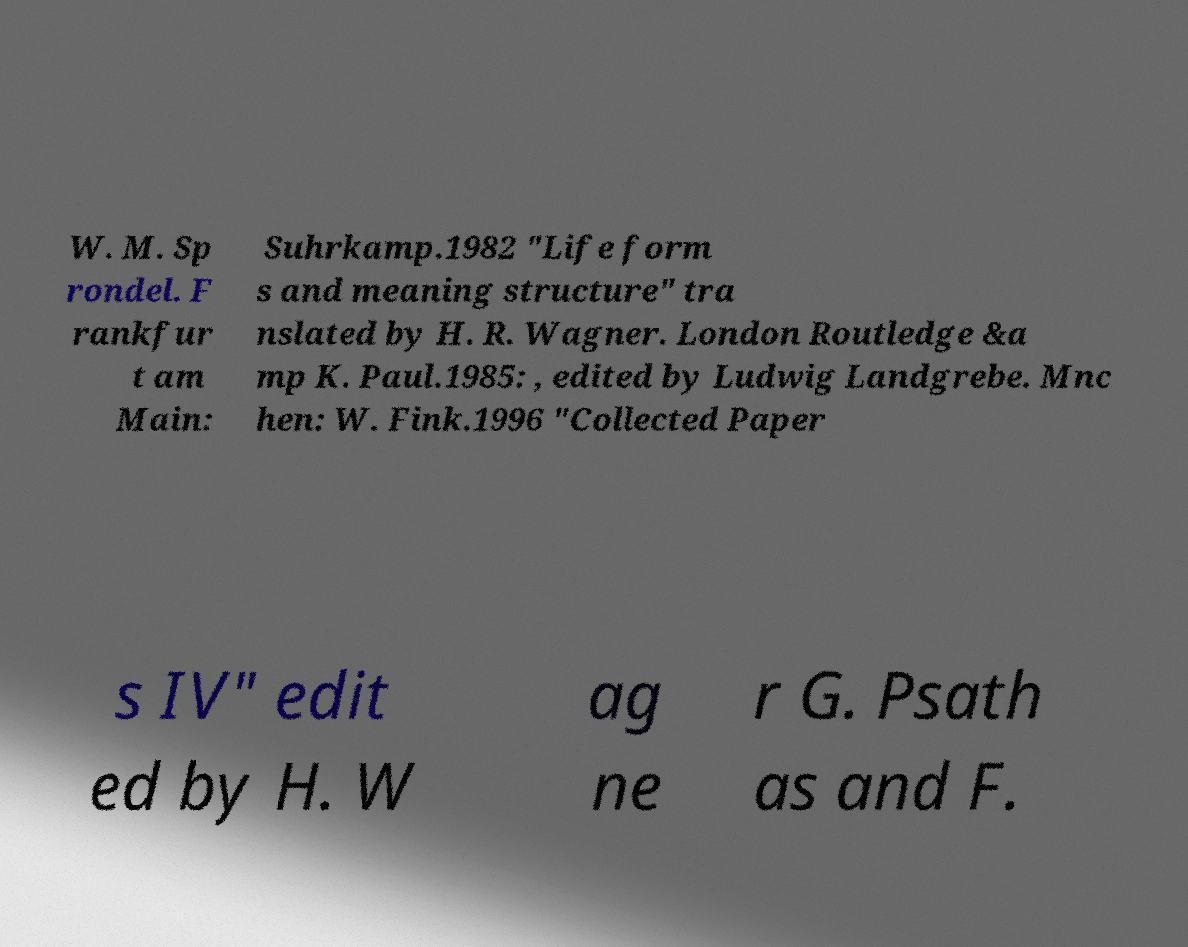Can you accurately transcribe the text from the provided image for me? W. M. Sp rondel. F rankfur t am Main: Suhrkamp.1982 "Life form s and meaning structure" tra nslated by H. R. Wagner. London Routledge &a mp K. Paul.1985: , edited by Ludwig Landgrebe. Mnc hen: W. Fink.1996 "Collected Paper s IV" edit ed by H. W ag ne r G. Psath as and F. 